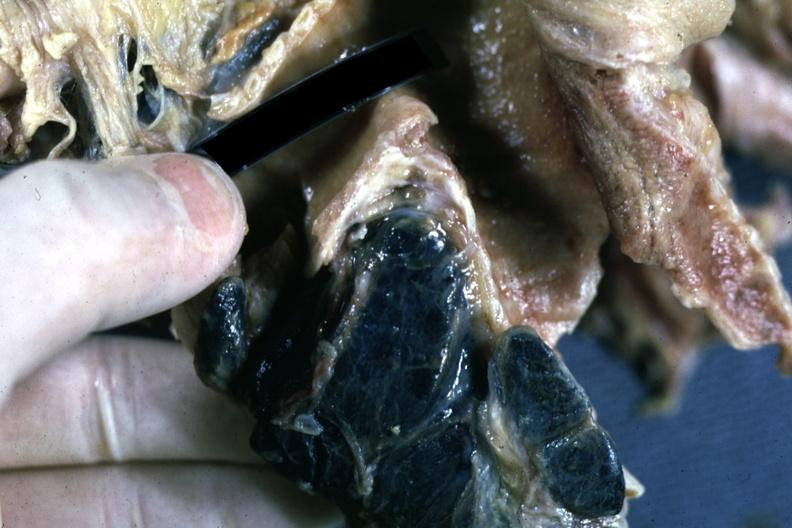what are carinal nodes shown close-up nodes with black pigment?
Answer the question using a single word or phrase. Nodes filled 